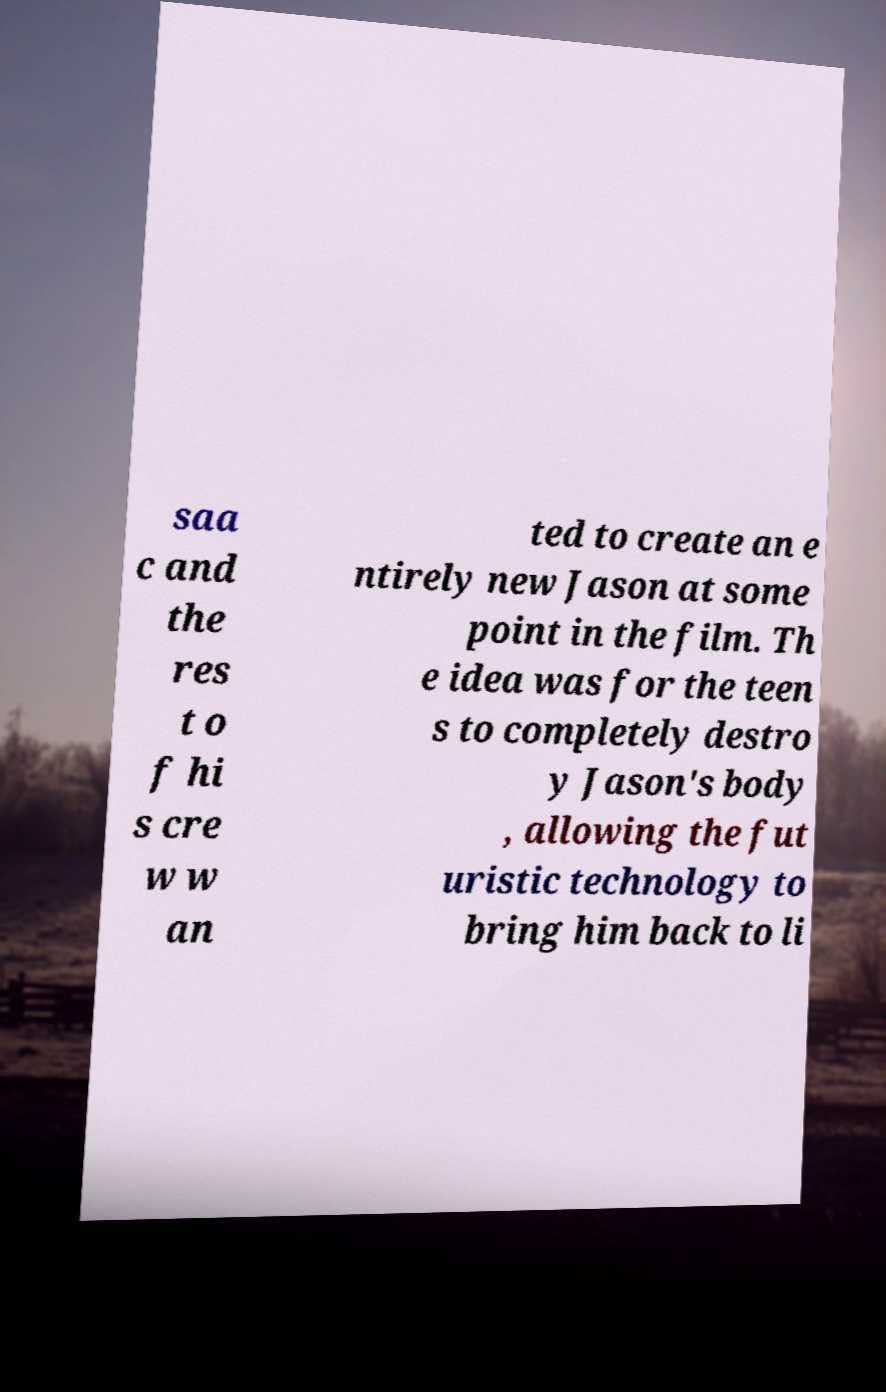Could you extract and type out the text from this image? saa c and the res t o f hi s cre w w an ted to create an e ntirely new Jason at some point in the film. Th e idea was for the teen s to completely destro y Jason's body , allowing the fut uristic technology to bring him back to li 